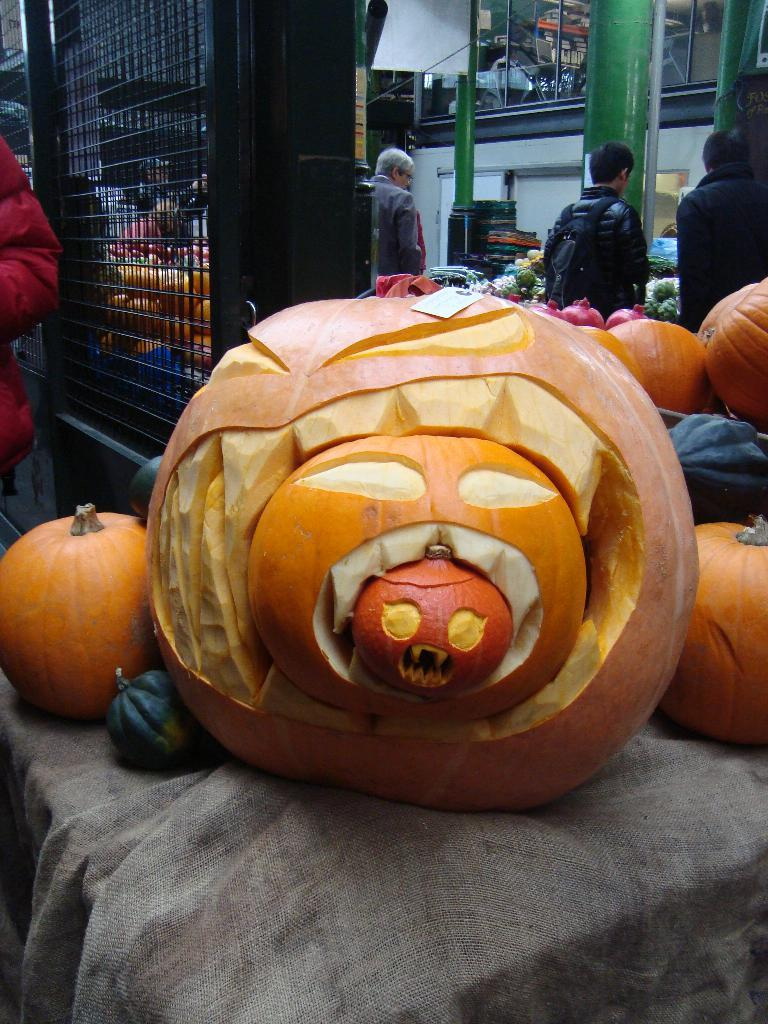What objects are placed on the cloth in the center of the image? There are pumpkins placed on a cloth in the center of the image. What can be seen in the background of the image? There are persons standing in the background of the image. What are the persons standing in front of? The persons are in front of vegetables. How many children are playing with the waves in the image? There are no children or waves present in the image. 